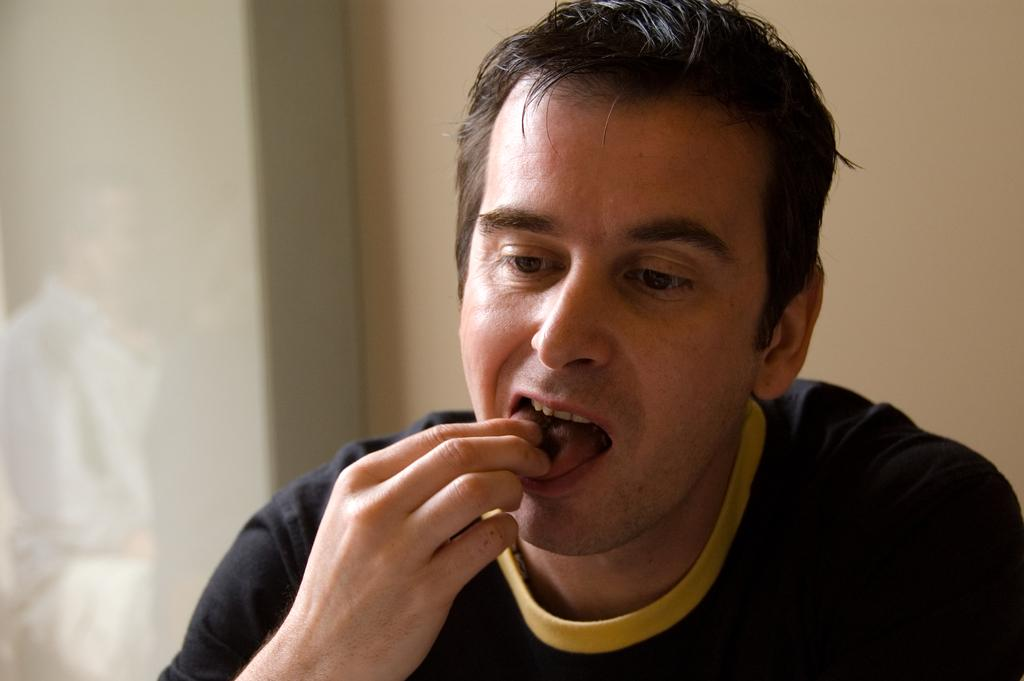Who is present in the image? There is a man in the image. What is the man doing in the image? The man is eating food. What can be seen in the background of the image? There is a wall and an object in the background of the image. Can you describe the reflection on the left side of the image? There is a reflection of a human on the left side of the image. What is the weather like in the image? The provided facts do not mention any information about the weather, so it cannot be determined from the image. 